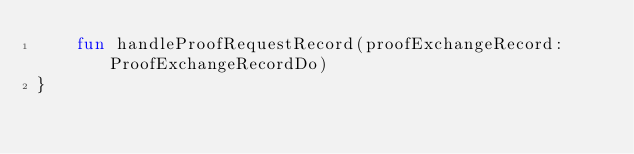Convert code to text. <code><loc_0><loc_0><loc_500><loc_500><_Kotlin_>    fun handleProofRequestRecord(proofExchangeRecord: ProofExchangeRecordDo)
}
</code> 